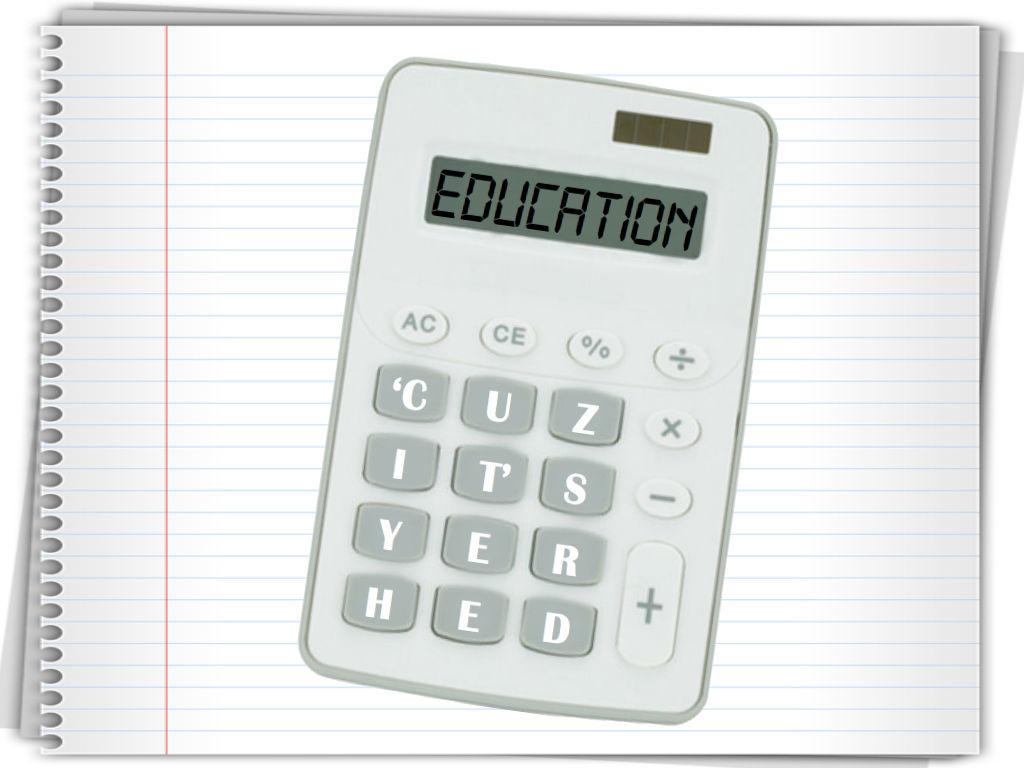<image>
Share a concise interpretation of the image provided. A calculator with the word education on the screen is on top of a spiral notebook. 